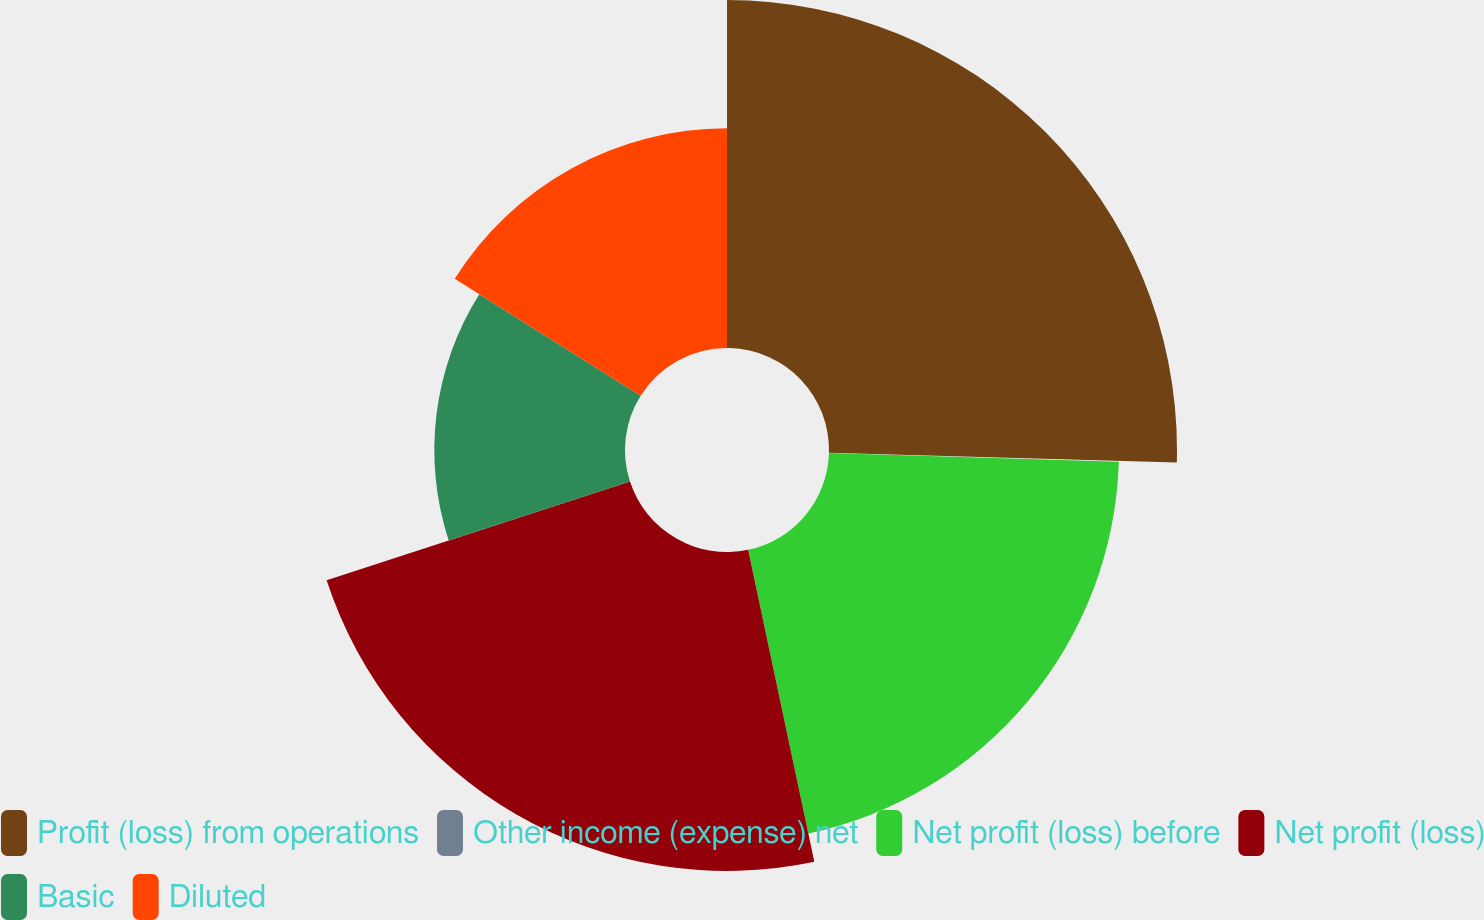Convert chart. <chart><loc_0><loc_0><loc_500><loc_500><pie_chart><fcel>Profit (loss) from operations<fcel>Other income (expense) net<fcel>Net profit (loss) before<fcel>Net profit (loss)<fcel>Basic<fcel>Diluted<nl><fcel>25.44%<fcel>0.03%<fcel>21.2%<fcel>23.32%<fcel>13.94%<fcel>16.06%<nl></chart> 